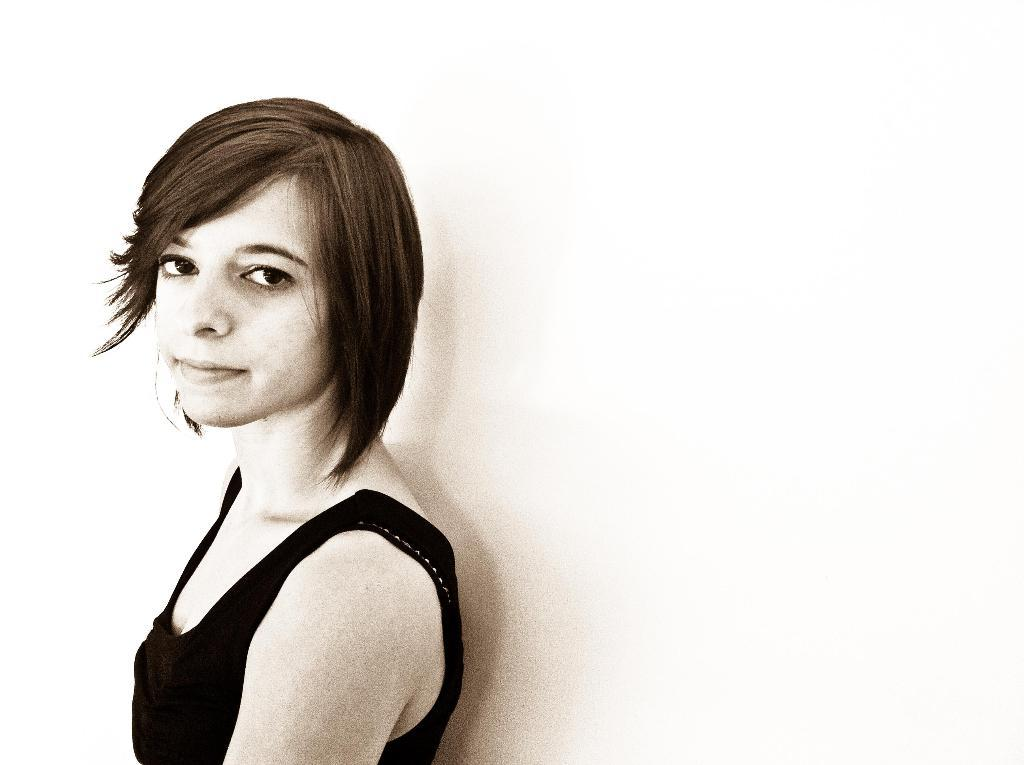What is the main subject of the image? There is a person in the image. What is the person wearing? The person is wearing a black dress. Can you describe the person's posture in the image? The person appears to be standing. What is the color of the background in the image? The background of the image is white in color. What type of cent can be seen participating in the feast in the image? There is no cent or feast present in the image; it features a person wearing a black dress standing against a white background. Is there a boat visible in the image? No, there is no boat present in the image. 